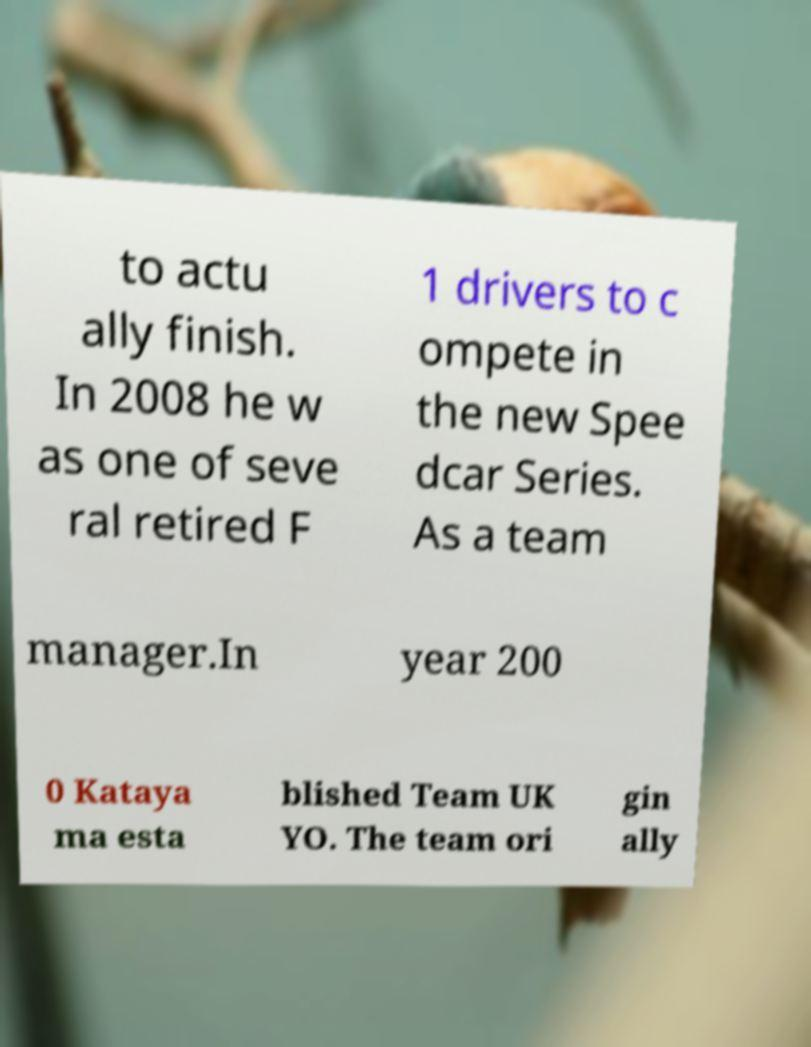Could you extract and type out the text from this image? to actu ally finish. In 2008 he w as one of seve ral retired F 1 drivers to c ompete in the new Spee dcar Series. As a team manager.In year 200 0 Kataya ma esta blished Team UK YO. The team ori gin ally 